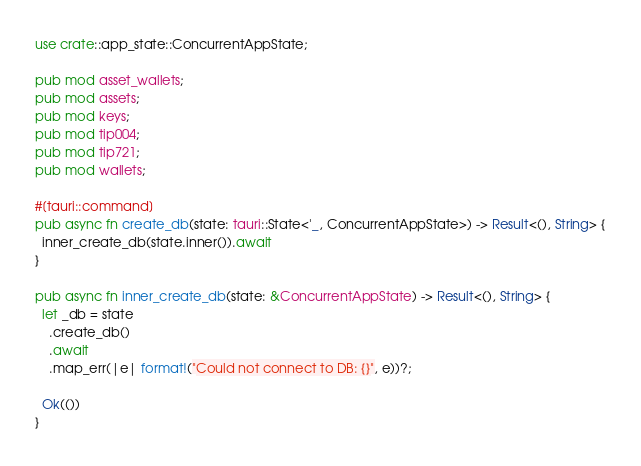Convert code to text. <code><loc_0><loc_0><loc_500><loc_500><_Rust_>
use crate::app_state::ConcurrentAppState;

pub mod asset_wallets;
pub mod assets;
pub mod keys;
pub mod tip004;
pub mod tip721;
pub mod wallets;

#[tauri::command]
pub async fn create_db(state: tauri::State<'_, ConcurrentAppState>) -> Result<(), String> {
  inner_create_db(state.inner()).await
}

pub async fn inner_create_db(state: &ConcurrentAppState) -> Result<(), String> {
  let _db = state
    .create_db()
    .await
    .map_err(|e| format!("Could not connect to DB: {}", e))?;

  Ok(())
}
</code> 